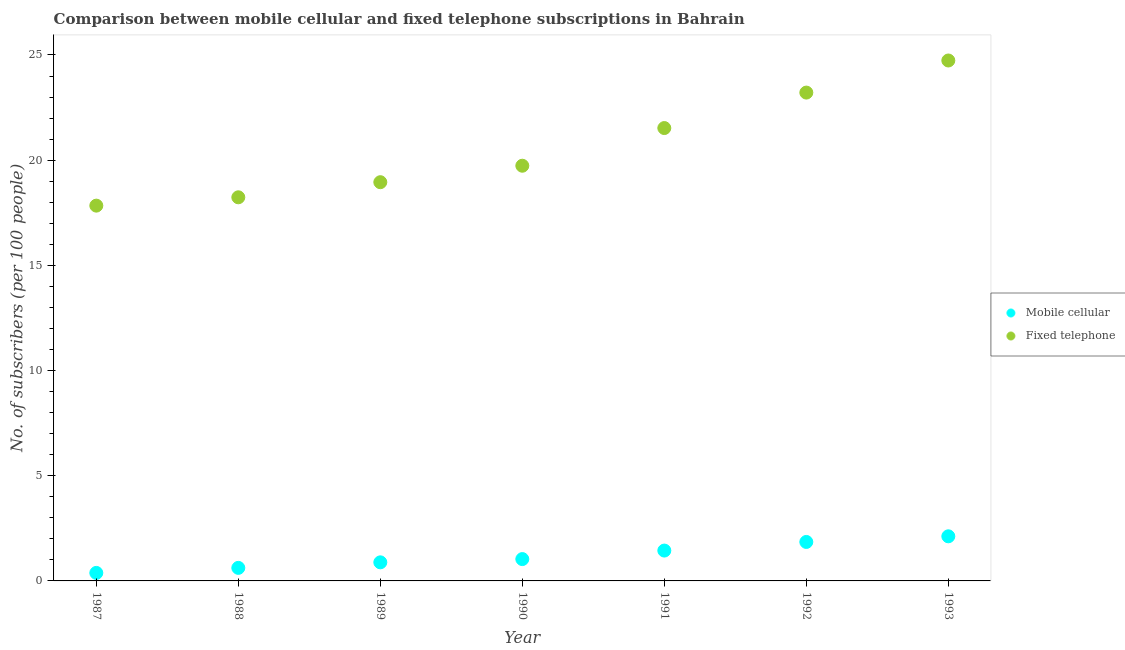Is the number of dotlines equal to the number of legend labels?
Make the answer very short. Yes. What is the number of fixed telephone subscribers in 1988?
Offer a very short reply. 18.24. Across all years, what is the maximum number of mobile cellular subscribers?
Ensure brevity in your answer.  2.12. Across all years, what is the minimum number of fixed telephone subscribers?
Provide a short and direct response. 17.84. In which year was the number of mobile cellular subscribers maximum?
Make the answer very short. 1993. What is the total number of fixed telephone subscribers in the graph?
Your response must be concise. 144.24. What is the difference between the number of fixed telephone subscribers in 1989 and that in 1990?
Offer a terse response. -0.78. What is the difference between the number of fixed telephone subscribers in 1989 and the number of mobile cellular subscribers in 1990?
Your answer should be compact. 17.91. What is the average number of mobile cellular subscribers per year?
Keep it short and to the point. 1.19. In the year 1991, what is the difference between the number of mobile cellular subscribers and number of fixed telephone subscribers?
Give a very brief answer. -20.08. In how many years, is the number of mobile cellular subscribers greater than 9?
Keep it short and to the point. 0. What is the ratio of the number of fixed telephone subscribers in 1987 to that in 1988?
Provide a short and direct response. 0.98. Is the difference between the number of fixed telephone subscribers in 1988 and 1991 greater than the difference between the number of mobile cellular subscribers in 1988 and 1991?
Ensure brevity in your answer.  No. What is the difference between the highest and the second highest number of mobile cellular subscribers?
Your answer should be very brief. 0.27. What is the difference between the highest and the lowest number of fixed telephone subscribers?
Offer a terse response. 6.9. In how many years, is the number of fixed telephone subscribers greater than the average number of fixed telephone subscribers taken over all years?
Make the answer very short. 3. Is the sum of the number of mobile cellular subscribers in 1989 and 1991 greater than the maximum number of fixed telephone subscribers across all years?
Offer a terse response. No. Does the number of fixed telephone subscribers monotonically increase over the years?
Give a very brief answer. Yes. Is the number of fixed telephone subscribers strictly greater than the number of mobile cellular subscribers over the years?
Provide a succinct answer. Yes. Are the values on the major ticks of Y-axis written in scientific E-notation?
Provide a succinct answer. No. Does the graph contain any zero values?
Make the answer very short. No. Does the graph contain grids?
Offer a very short reply. No. What is the title of the graph?
Keep it short and to the point. Comparison between mobile cellular and fixed telephone subscriptions in Bahrain. Does "Total Population" appear as one of the legend labels in the graph?
Offer a very short reply. No. What is the label or title of the Y-axis?
Keep it short and to the point. No. of subscribers (per 100 people). What is the No. of subscribers (per 100 people) of Mobile cellular in 1987?
Ensure brevity in your answer.  0.38. What is the No. of subscribers (per 100 people) of Fixed telephone in 1987?
Offer a very short reply. 17.84. What is the No. of subscribers (per 100 people) of Mobile cellular in 1988?
Give a very brief answer. 0.62. What is the No. of subscribers (per 100 people) in Fixed telephone in 1988?
Keep it short and to the point. 18.24. What is the No. of subscribers (per 100 people) of Mobile cellular in 1989?
Your response must be concise. 0.88. What is the No. of subscribers (per 100 people) of Fixed telephone in 1989?
Provide a succinct answer. 18.95. What is the No. of subscribers (per 100 people) of Mobile cellular in 1990?
Offer a terse response. 1.04. What is the No. of subscribers (per 100 people) of Fixed telephone in 1990?
Offer a very short reply. 19.74. What is the No. of subscribers (per 100 people) of Mobile cellular in 1991?
Ensure brevity in your answer.  1.44. What is the No. of subscribers (per 100 people) of Fixed telephone in 1991?
Offer a very short reply. 21.53. What is the No. of subscribers (per 100 people) of Mobile cellular in 1992?
Make the answer very short. 1.85. What is the No. of subscribers (per 100 people) in Fixed telephone in 1992?
Make the answer very short. 23.21. What is the No. of subscribers (per 100 people) in Mobile cellular in 1993?
Keep it short and to the point. 2.12. What is the No. of subscribers (per 100 people) of Fixed telephone in 1993?
Offer a terse response. 24.74. Across all years, what is the maximum No. of subscribers (per 100 people) of Mobile cellular?
Offer a very short reply. 2.12. Across all years, what is the maximum No. of subscribers (per 100 people) of Fixed telephone?
Ensure brevity in your answer.  24.74. Across all years, what is the minimum No. of subscribers (per 100 people) of Mobile cellular?
Make the answer very short. 0.38. Across all years, what is the minimum No. of subscribers (per 100 people) in Fixed telephone?
Provide a short and direct response. 17.84. What is the total No. of subscribers (per 100 people) in Mobile cellular in the graph?
Your answer should be very brief. 8.34. What is the total No. of subscribers (per 100 people) of Fixed telephone in the graph?
Make the answer very short. 144.24. What is the difference between the No. of subscribers (per 100 people) in Mobile cellular in 1987 and that in 1988?
Your answer should be compact. -0.24. What is the difference between the No. of subscribers (per 100 people) of Fixed telephone in 1987 and that in 1988?
Offer a terse response. -0.4. What is the difference between the No. of subscribers (per 100 people) in Mobile cellular in 1987 and that in 1989?
Offer a terse response. -0.5. What is the difference between the No. of subscribers (per 100 people) of Fixed telephone in 1987 and that in 1989?
Keep it short and to the point. -1.11. What is the difference between the No. of subscribers (per 100 people) of Mobile cellular in 1987 and that in 1990?
Provide a succinct answer. -0.66. What is the difference between the No. of subscribers (per 100 people) of Fixed telephone in 1987 and that in 1990?
Your response must be concise. -1.9. What is the difference between the No. of subscribers (per 100 people) of Mobile cellular in 1987 and that in 1991?
Provide a succinct answer. -1.06. What is the difference between the No. of subscribers (per 100 people) of Fixed telephone in 1987 and that in 1991?
Your answer should be very brief. -3.69. What is the difference between the No. of subscribers (per 100 people) in Mobile cellular in 1987 and that in 1992?
Your answer should be very brief. -1.47. What is the difference between the No. of subscribers (per 100 people) in Fixed telephone in 1987 and that in 1992?
Keep it short and to the point. -5.37. What is the difference between the No. of subscribers (per 100 people) in Mobile cellular in 1987 and that in 1993?
Provide a succinct answer. -1.74. What is the difference between the No. of subscribers (per 100 people) in Fixed telephone in 1987 and that in 1993?
Offer a very short reply. -6.9. What is the difference between the No. of subscribers (per 100 people) of Mobile cellular in 1988 and that in 1989?
Provide a short and direct response. -0.26. What is the difference between the No. of subscribers (per 100 people) in Fixed telephone in 1988 and that in 1989?
Your response must be concise. -0.72. What is the difference between the No. of subscribers (per 100 people) of Mobile cellular in 1988 and that in 1990?
Keep it short and to the point. -0.42. What is the difference between the No. of subscribers (per 100 people) of Fixed telephone in 1988 and that in 1990?
Give a very brief answer. -1.5. What is the difference between the No. of subscribers (per 100 people) in Mobile cellular in 1988 and that in 1991?
Keep it short and to the point. -0.82. What is the difference between the No. of subscribers (per 100 people) of Fixed telephone in 1988 and that in 1991?
Provide a succinct answer. -3.29. What is the difference between the No. of subscribers (per 100 people) of Mobile cellular in 1988 and that in 1992?
Your answer should be very brief. -1.23. What is the difference between the No. of subscribers (per 100 people) of Fixed telephone in 1988 and that in 1992?
Your answer should be very brief. -4.98. What is the difference between the No. of subscribers (per 100 people) in Mobile cellular in 1988 and that in 1993?
Make the answer very short. -1.5. What is the difference between the No. of subscribers (per 100 people) in Fixed telephone in 1988 and that in 1993?
Keep it short and to the point. -6.5. What is the difference between the No. of subscribers (per 100 people) in Mobile cellular in 1989 and that in 1990?
Your response must be concise. -0.15. What is the difference between the No. of subscribers (per 100 people) of Fixed telephone in 1989 and that in 1990?
Offer a terse response. -0.78. What is the difference between the No. of subscribers (per 100 people) of Mobile cellular in 1989 and that in 1991?
Offer a terse response. -0.56. What is the difference between the No. of subscribers (per 100 people) of Fixed telephone in 1989 and that in 1991?
Keep it short and to the point. -2.57. What is the difference between the No. of subscribers (per 100 people) in Mobile cellular in 1989 and that in 1992?
Your answer should be very brief. -0.97. What is the difference between the No. of subscribers (per 100 people) of Fixed telephone in 1989 and that in 1992?
Ensure brevity in your answer.  -4.26. What is the difference between the No. of subscribers (per 100 people) of Mobile cellular in 1989 and that in 1993?
Your answer should be compact. -1.24. What is the difference between the No. of subscribers (per 100 people) of Fixed telephone in 1989 and that in 1993?
Your response must be concise. -5.79. What is the difference between the No. of subscribers (per 100 people) in Mobile cellular in 1990 and that in 1991?
Offer a terse response. -0.41. What is the difference between the No. of subscribers (per 100 people) of Fixed telephone in 1990 and that in 1991?
Give a very brief answer. -1.79. What is the difference between the No. of subscribers (per 100 people) in Mobile cellular in 1990 and that in 1992?
Keep it short and to the point. -0.81. What is the difference between the No. of subscribers (per 100 people) in Fixed telephone in 1990 and that in 1992?
Offer a terse response. -3.48. What is the difference between the No. of subscribers (per 100 people) of Mobile cellular in 1990 and that in 1993?
Keep it short and to the point. -1.08. What is the difference between the No. of subscribers (per 100 people) in Fixed telephone in 1990 and that in 1993?
Offer a very short reply. -5. What is the difference between the No. of subscribers (per 100 people) of Mobile cellular in 1991 and that in 1992?
Your answer should be compact. -0.41. What is the difference between the No. of subscribers (per 100 people) in Fixed telephone in 1991 and that in 1992?
Your answer should be compact. -1.69. What is the difference between the No. of subscribers (per 100 people) of Mobile cellular in 1991 and that in 1993?
Offer a very short reply. -0.68. What is the difference between the No. of subscribers (per 100 people) in Fixed telephone in 1991 and that in 1993?
Your response must be concise. -3.21. What is the difference between the No. of subscribers (per 100 people) in Mobile cellular in 1992 and that in 1993?
Your answer should be compact. -0.27. What is the difference between the No. of subscribers (per 100 people) in Fixed telephone in 1992 and that in 1993?
Offer a terse response. -1.53. What is the difference between the No. of subscribers (per 100 people) in Mobile cellular in 1987 and the No. of subscribers (per 100 people) in Fixed telephone in 1988?
Offer a very short reply. -17.85. What is the difference between the No. of subscribers (per 100 people) of Mobile cellular in 1987 and the No. of subscribers (per 100 people) of Fixed telephone in 1989?
Offer a very short reply. -18.57. What is the difference between the No. of subscribers (per 100 people) in Mobile cellular in 1987 and the No. of subscribers (per 100 people) in Fixed telephone in 1990?
Offer a very short reply. -19.35. What is the difference between the No. of subscribers (per 100 people) in Mobile cellular in 1987 and the No. of subscribers (per 100 people) in Fixed telephone in 1991?
Your response must be concise. -21.15. What is the difference between the No. of subscribers (per 100 people) in Mobile cellular in 1987 and the No. of subscribers (per 100 people) in Fixed telephone in 1992?
Make the answer very short. -22.83. What is the difference between the No. of subscribers (per 100 people) of Mobile cellular in 1987 and the No. of subscribers (per 100 people) of Fixed telephone in 1993?
Your answer should be very brief. -24.36. What is the difference between the No. of subscribers (per 100 people) in Mobile cellular in 1988 and the No. of subscribers (per 100 people) in Fixed telephone in 1989?
Ensure brevity in your answer.  -18.33. What is the difference between the No. of subscribers (per 100 people) of Mobile cellular in 1988 and the No. of subscribers (per 100 people) of Fixed telephone in 1990?
Provide a succinct answer. -19.12. What is the difference between the No. of subscribers (per 100 people) in Mobile cellular in 1988 and the No. of subscribers (per 100 people) in Fixed telephone in 1991?
Provide a short and direct response. -20.91. What is the difference between the No. of subscribers (per 100 people) in Mobile cellular in 1988 and the No. of subscribers (per 100 people) in Fixed telephone in 1992?
Provide a short and direct response. -22.59. What is the difference between the No. of subscribers (per 100 people) of Mobile cellular in 1988 and the No. of subscribers (per 100 people) of Fixed telephone in 1993?
Offer a very short reply. -24.12. What is the difference between the No. of subscribers (per 100 people) in Mobile cellular in 1989 and the No. of subscribers (per 100 people) in Fixed telephone in 1990?
Offer a terse response. -18.85. What is the difference between the No. of subscribers (per 100 people) in Mobile cellular in 1989 and the No. of subscribers (per 100 people) in Fixed telephone in 1991?
Keep it short and to the point. -20.64. What is the difference between the No. of subscribers (per 100 people) in Mobile cellular in 1989 and the No. of subscribers (per 100 people) in Fixed telephone in 1992?
Offer a terse response. -22.33. What is the difference between the No. of subscribers (per 100 people) of Mobile cellular in 1989 and the No. of subscribers (per 100 people) of Fixed telephone in 1993?
Ensure brevity in your answer.  -23.85. What is the difference between the No. of subscribers (per 100 people) in Mobile cellular in 1990 and the No. of subscribers (per 100 people) in Fixed telephone in 1991?
Keep it short and to the point. -20.49. What is the difference between the No. of subscribers (per 100 people) of Mobile cellular in 1990 and the No. of subscribers (per 100 people) of Fixed telephone in 1992?
Offer a very short reply. -22.17. What is the difference between the No. of subscribers (per 100 people) in Mobile cellular in 1990 and the No. of subscribers (per 100 people) in Fixed telephone in 1993?
Ensure brevity in your answer.  -23.7. What is the difference between the No. of subscribers (per 100 people) of Mobile cellular in 1991 and the No. of subscribers (per 100 people) of Fixed telephone in 1992?
Your response must be concise. -21.77. What is the difference between the No. of subscribers (per 100 people) in Mobile cellular in 1991 and the No. of subscribers (per 100 people) in Fixed telephone in 1993?
Give a very brief answer. -23.29. What is the difference between the No. of subscribers (per 100 people) of Mobile cellular in 1992 and the No. of subscribers (per 100 people) of Fixed telephone in 1993?
Your answer should be compact. -22.89. What is the average No. of subscribers (per 100 people) in Mobile cellular per year?
Offer a very short reply. 1.19. What is the average No. of subscribers (per 100 people) in Fixed telephone per year?
Offer a very short reply. 20.61. In the year 1987, what is the difference between the No. of subscribers (per 100 people) in Mobile cellular and No. of subscribers (per 100 people) in Fixed telephone?
Make the answer very short. -17.46. In the year 1988, what is the difference between the No. of subscribers (per 100 people) of Mobile cellular and No. of subscribers (per 100 people) of Fixed telephone?
Offer a terse response. -17.61. In the year 1989, what is the difference between the No. of subscribers (per 100 people) of Mobile cellular and No. of subscribers (per 100 people) of Fixed telephone?
Your answer should be compact. -18.07. In the year 1990, what is the difference between the No. of subscribers (per 100 people) of Mobile cellular and No. of subscribers (per 100 people) of Fixed telephone?
Your answer should be very brief. -18.7. In the year 1991, what is the difference between the No. of subscribers (per 100 people) of Mobile cellular and No. of subscribers (per 100 people) of Fixed telephone?
Offer a terse response. -20.08. In the year 1992, what is the difference between the No. of subscribers (per 100 people) of Mobile cellular and No. of subscribers (per 100 people) of Fixed telephone?
Ensure brevity in your answer.  -21.36. In the year 1993, what is the difference between the No. of subscribers (per 100 people) in Mobile cellular and No. of subscribers (per 100 people) in Fixed telephone?
Provide a succinct answer. -22.62. What is the ratio of the No. of subscribers (per 100 people) of Mobile cellular in 1987 to that in 1988?
Your answer should be compact. 0.61. What is the ratio of the No. of subscribers (per 100 people) in Fixed telephone in 1987 to that in 1988?
Your response must be concise. 0.98. What is the ratio of the No. of subscribers (per 100 people) in Mobile cellular in 1987 to that in 1989?
Provide a succinct answer. 0.43. What is the ratio of the No. of subscribers (per 100 people) in Fixed telephone in 1987 to that in 1989?
Give a very brief answer. 0.94. What is the ratio of the No. of subscribers (per 100 people) in Mobile cellular in 1987 to that in 1990?
Offer a terse response. 0.37. What is the ratio of the No. of subscribers (per 100 people) in Fixed telephone in 1987 to that in 1990?
Your response must be concise. 0.9. What is the ratio of the No. of subscribers (per 100 people) of Mobile cellular in 1987 to that in 1991?
Offer a terse response. 0.26. What is the ratio of the No. of subscribers (per 100 people) of Fixed telephone in 1987 to that in 1991?
Make the answer very short. 0.83. What is the ratio of the No. of subscribers (per 100 people) of Mobile cellular in 1987 to that in 1992?
Your response must be concise. 0.21. What is the ratio of the No. of subscribers (per 100 people) in Fixed telephone in 1987 to that in 1992?
Keep it short and to the point. 0.77. What is the ratio of the No. of subscribers (per 100 people) in Mobile cellular in 1987 to that in 1993?
Provide a short and direct response. 0.18. What is the ratio of the No. of subscribers (per 100 people) of Fixed telephone in 1987 to that in 1993?
Your answer should be very brief. 0.72. What is the ratio of the No. of subscribers (per 100 people) of Mobile cellular in 1988 to that in 1989?
Your answer should be very brief. 0.7. What is the ratio of the No. of subscribers (per 100 people) in Fixed telephone in 1988 to that in 1989?
Keep it short and to the point. 0.96. What is the ratio of the No. of subscribers (per 100 people) in Mobile cellular in 1988 to that in 1990?
Your answer should be compact. 0.6. What is the ratio of the No. of subscribers (per 100 people) of Fixed telephone in 1988 to that in 1990?
Your answer should be compact. 0.92. What is the ratio of the No. of subscribers (per 100 people) of Mobile cellular in 1988 to that in 1991?
Keep it short and to the point. 0.43. What is the ratio of the No. of subscribers (per 100 people) in Fixed telephone in 1988 to that in 1991?
Your answer should be compact. 0.85. What is the ratio of the No. of subscribers (per 100 people) in Mobile cellular in 1988 to that in 1992?
Make the answer very short. 0.33. What is the ratio of the No. of subscribers (per 100 people) of Fixed telephone in 1988 to that in 1992?
Offer a terse response. 0.79. What is the ratio of the No. of subscribers (per 100 people) in Mobile cellular in 1988 to that in 1993?
Ensure brevity in your answer.  0.29. What is the ratio of the No. of subscribers (per 100 people) of Fixed telephone in 1988 to that in 1993?
Your answer should be very brief. 0.74. What is the ratio of the No. of subscribers (per 100 people) in Mobile cellular in 1989 to that in 1990?
Offer a very short reply. 0.85. What is the ratio of the No. of subscribers (per 100 people) in Fixed telephone in 1989 to that in 1990?
Offer a very short reply. 0.96. What is the ratio of the No. of subscribers (per 100 people) of Mobile cellular in 1989 to that in 1991?
Your response must be concise. 0.61. What is the ratio of the No. of subscribers (per 100 people) of Fixed telephone in 1989 to that in 1991?
Make the answer very short. 0.88. What is the ratio of the No. of subscribers (per 100 people) of Mobile cellular in 1989 to that in 1992?
Offer a terse response. 0.48. What is the ratio of the No. of subscribers (per 100 people) of Fixed telephone in 1989 to that in 1992?
Your response must be concise. 0.82. What is the ratio of the No. of subscribers (per 100 people) in Mobile cellular in 1989 to that in 1993?
Provide a succinct answer. 0.42. What is the ratio of the No. of subscribers (per 100 people) in Fixed telephone in 1989 to that in 1993?
Your answer should be very brief. 0.77. What is the ratio of the No. of subscribers (per 100 people) in Mobile cellular in 1990 to that in 1991?
Keep it short and to the point. 0.72. What is the ratio of the No. of subscribers (per 100 people) of Fixed telephone in 1990 to that in 1991?
Your answer should be compact. 0.92. What is the ratio of the No. of subscribers (per 100 people) in Mobile cellular in 1990 to that in 1992?
Provide a succinct answer. 0.56. What is the ratio of the No. of subscribers (per 100 people) in Fixed telephone in 1990 to that in 1992?
Give a very brief answer. 0.85. What is the ratio of the No. of subscribers (per 100 people) in Mobile cellular in 1990 to that in 1993?
Make the answer very short. 0.49. What is the ratio of the No. of subscribers (per 100 people) in Fixed telephone in 1990 to that in 1993?
Provide a short and direct response. 0.8. What is the ratio of the No. of subscribers (per 100 people) of Mobile cellular in 1991 to that in 1992?
Keep it short and to the point. 0.78. What is the ratio of the No. of subscribers (per 100 people) of Fixed telephone in 1991 to that in 1992?
Give a very brief answer. 0.93. What is the ratio of the No. of subscribers (per 100 people) in Mobile cellular in 1991 to that in 1993?
Keep it short and to the point. 0.68. What is the ratio of the No. of subscribers (per 100 people) in Fixed telephone in 1991 to that in 1993?
Give a very brief answer. 0.87. What is the ratio of the No. of subscribers (per 100 people) of Mobile cellular in 1992 to that in 1993?
Offer a terse response. 0.87. What is the ratio of the No. of subscribers (per 100 people) of Fixed telephone in 1992 to that in 1993?
Provide a short and direct response. 0.94. What is the difference between the highest and the second highest No. of subscribers (per 100 people) of Mobile cellular?
Your response must be concise. 0.27. What is the difference between the highest and the second highest No. of subscribers (per 100 people) of Fixed telephone?
Your response must be concise. 1.53. What is the difference between the highest and the lowest No. of subscribers (per 100 people) of Mobile cellular?
Your answer should be compact. 1.74. What is the difference between the highest and the lowest No. of subscribers (per 100 people) of Fixed telephone?
Ensure brevity in your answer.  6.9. 